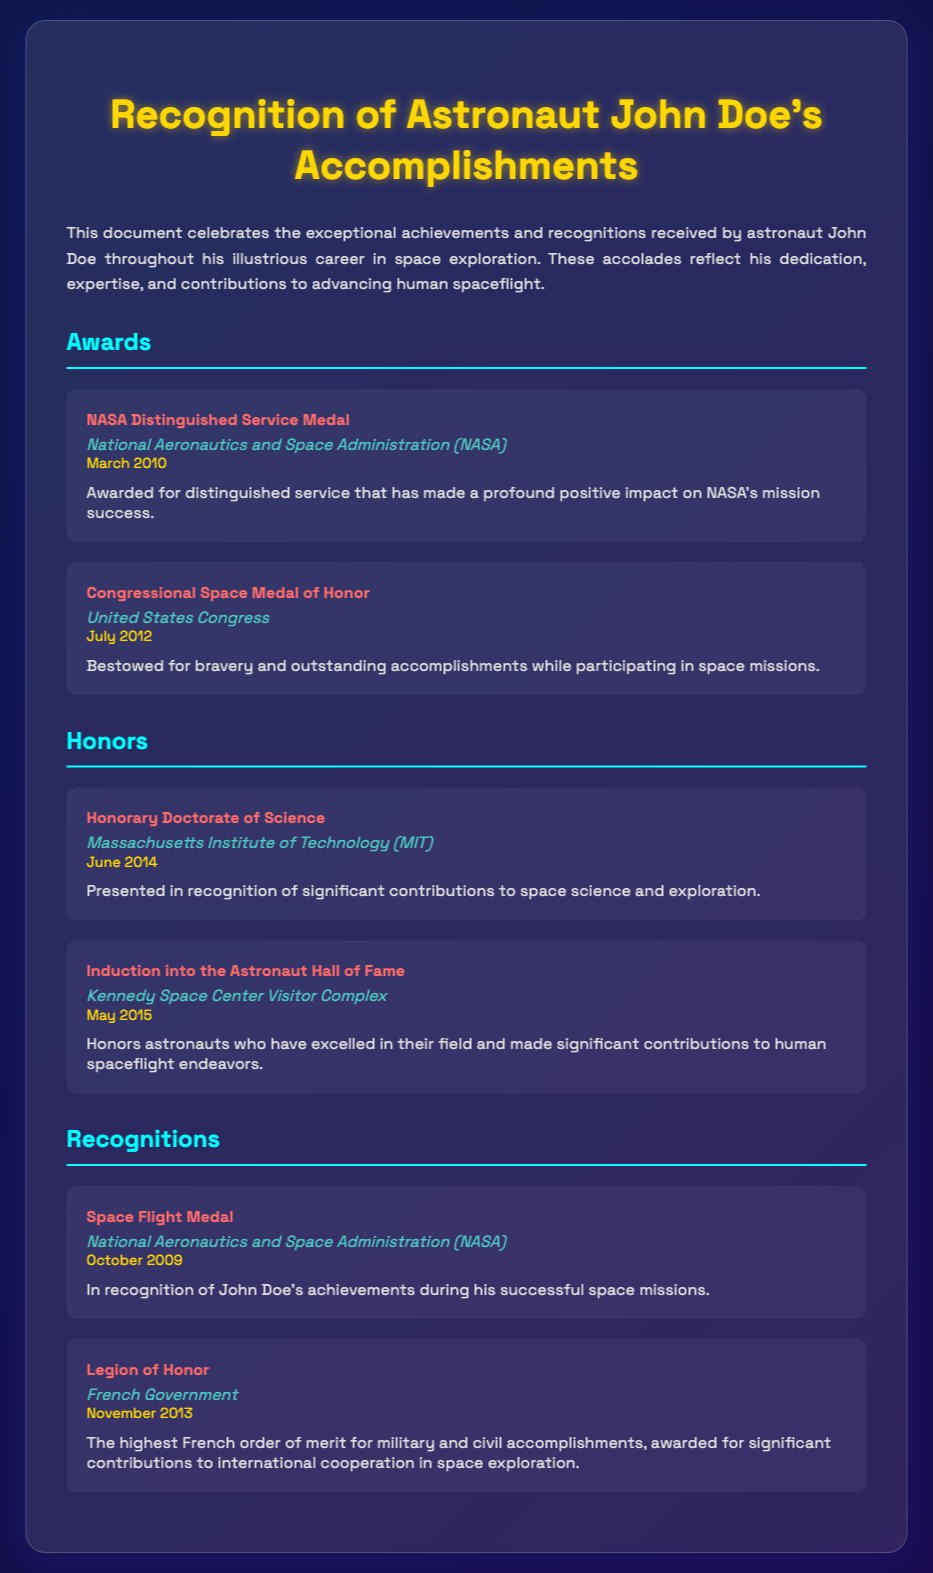What is the title of the document? The title of the document is stated at the top, which relates to astronaut John Doe’s accomplishments.
Answer: Recognition of Astronaut John Doe's Accomplishments Who awarded the Congressional Space Medal of Honor? The awarding organization is specified in the context of the medal mentioned.
Answer: United States Congress When was John Doe awarded the NASA Distinguished Service Medal? The specific date associated with the award is highlighted in the document.
Answer: March 2010 What honor did John Doe receive in June 2014? The document lists specific honors along with their dates, identifying June 2014 as the time for this particular honor.
Answer: Honorary Doctorate of Science How many recognitions are listed in the document? The number of recognitions can be derived from counting the entries in the corresponding section.
Answer: 2 What organization awarded John Doe the Space Flight Medal? The organization associated with the award is mentioned in the details of that award.
Answer: National Aeronautics and Space Administration (NASA) Which award was received last according to the document? The last award mentioned helps to identify the most recent recognition noted.
Answer: Legion of Honor What is the significance of the Induction into the Astronaut Hall of Fame? This reflects information regarding what the induction signifies as mentioned in the description.
Answer: Honoring astronauts who have excelled Why did John Doe receive the Legion of Honor? The document provides a brief description of the reason for the award.
Answer: Significant contributions to international cooperation in space exploration 